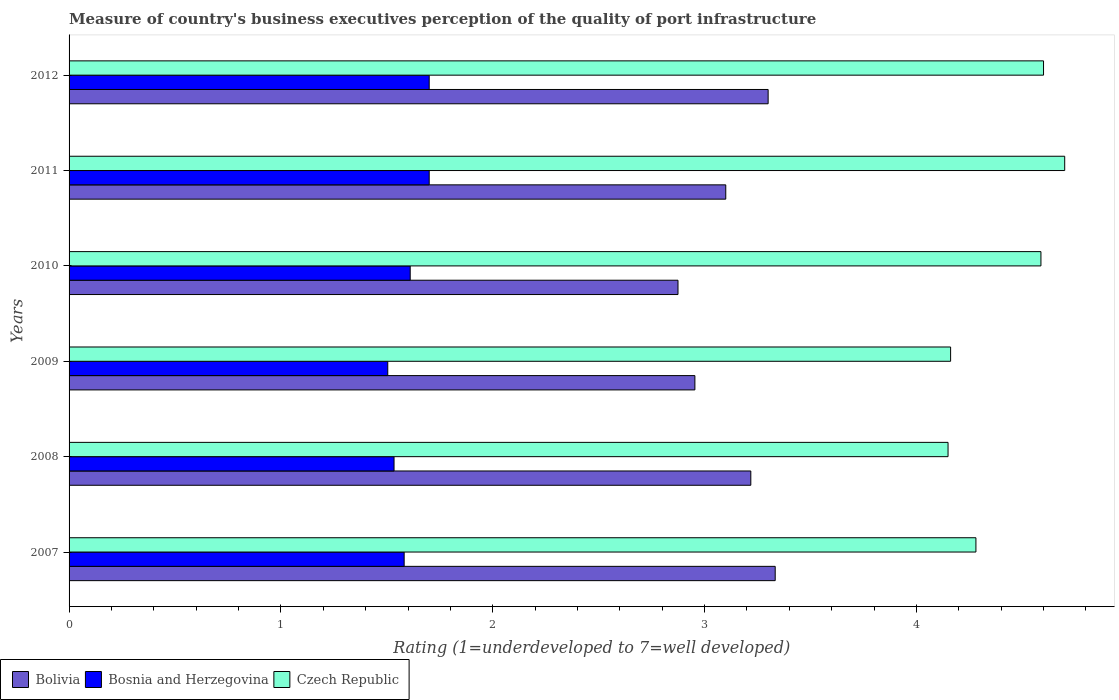How many different coloured bars are there?
Ensure brevity in your answer.  3. Are the number of bars per tick equal to the number of legend labels?
Your answer should be very brief. Yes. Are the number of bars on each tick of the Y-axis equal?
Your answer should be very brief. Yes. How many bars are there on the 3rd tick from the top?
Ensure brevity in your answer.  3. How many bars are there on the 1st tick from the bottom?
Your response must be concise. 3. In how many cases, is the number of bars for a given year not equal to the number of legend labels?
Your response must be concise. 0. Across all years, what is the minimum ratings of the quality of port infrastructure in Bosnia and Herzegovina?
Make the answer very short. 1.5. In which year was the ratings of the quality of port infrastructure in Bolivia minimum?
Provide a succinct answer. 2010. What is the total ratings of the quality of port infrastructure in Czech Republic in the graph?
Keep it short and to the point. 26.48. What is the difference between the ratings of the quality of port infrastructure in Bolivia in 2008 and that in 2011?
Make the answer very short. 0.12. What is the difference between the ratings of the quality of port infrastructure in Czech Republic in 2011 and the ratings of the quality of port infrastructure in Bolivia in 2008?
Keep it short and to the point. 1.48. What is the average ratings of the quality of port infrastructure in Bolivia per year?
Offer a terse response. 3.13. In the year 2009, what is the difference between the ratings of the quality of port infrastructure in Bosnia and Herzegovina and ratings of the quality of port infrastructure in Bolivia?
Offer a very short reply. -1.45. In how many years, is the ratings of the quality of port infrastructure in Bolivia greater than 3.6 ?
Your answer should be compact. 0. What is the ratio of the ratings of the quality of port infrastructure in Czech Republic in 2007 to that in 2012?
Provide a short and direct response. 0.93. Is the ratings of the quality of port infrastructure in Bosnia and Herzegovina in 2010 less than that in 2011?
Give a very brief answer. Yes. Is the difference between the ratings of the quality of port infrastructure in Bosnia and Herzegovina in 2008 and 2009 greater than the difference between the ratings of the quality of port infrastructure in Bolivia in 2008 and 2009?
Keep it short and to the point. No. What is the difference between the highest and the second highest ratings of the quality of port infrastructure in Czech Republic?
Make the answer very short. 0.1. What is the difference between the highest and the lowest ratings of the quality of port infrastructure in Czech Republic?
Give a very brief answer. 0.55. In how many years, is the ratings of the quality of port infrastructure in Czech Republic greater than the average ratings of the quality of port infrastructure in Czech Republic taken over all years?
Offer a very short reply. 3. What does the 1st bar from the top in 2007 represents?
Provide a succinct answer. Czech Republic. What does the 1st bar from the bottom in 2011 represents?
Provide a succinct answer. Bolivia. Is it the case that in every year, the sum of the ratings of the quality of port infrastructure in Bolivia and ratings of the quality of port infrastructure in Czech Republic is greater than the ratings of the quality of port infrastructure in Bosnia and Herzegovina?
Offer a terse response. Yes. How many bars are there?
Make the answer very short. 18. Are all the bars in the graph horizontal?
Provide a succinct answer. Yes. What is the difference between two consecutive major ticks on the X-axis?
Provide a succinct answer. 1. Are the values on the major ticks of X-axis written in scientific E-notation?
Your response must be concise. No. Where does the legend appear in the graph?
Provide a short and direct response. Bottom left. How many legend labels are there?
Give a very brief answer. 3. What is the title of the graph?
Your answer should be compact. Measure of country's business executives perception of the quality of port infrastructure. Does "Costa Rica" appear as one of the legend labels in the graph?
Provide a short and direct response. No. What is the label or title of the X-axis?
Provide a succinct answer. Rating (1=underdeveloped to 7=well developed). What is the Rating (1=underdeveloped to 7=well developed) of Bolivia in 2007?
Offer a very short reply. 3.33. What is the Rating (1=underdeveloped to 7=well developed) in Bosnia and Herzegovina in 2007?
Make the answer very short. 1.58. What is the Rating (1=underdeveloped to 7=well developed) of Czech Republic in 2007?
Give a very brief answer. 4.28. What is the Rating (1=underdeveloped to 7=well developed) in Bolivia in 2008?
Give a very brief answer. 3.22. What is the Rating (1=underdeveloped to 7=well developed) in Bosnia and Herzegovina in 2008?
Keep it short and to the point. 1.53. What is the Rating (1=underdeveloped to 7=well developed) of Czech Republic in 2008?
Ensure brevity in your answer.  4.15. What is the Rating (1=underdeveloped to 7=well developed) in Bolivia in 2009?
Your answer should be very brief. 2.95. What is the Rating (1=underdeveloped to 7=well developed) in Bosnia and Herzegovina in 2009?
Offer a very short reply. 1.5. What is the Rating (1=underdeveloped to 7=well developed) of Czech Republic in 2009?
Offer a terse response. 4.16. What is the Rating (1=underdeveloped to 7=well developed) in Bolivia in 2010?
Your response must be concise. 2.87. What is the Rating (1=underdeveloped to 7=well developed) in Bosnia and Herzegovina in 2010?
Make the answer very short. 1.61. What is the Rating (1=underdeveloped to 7=well developed) in Czech Republic in 2010?
Your answer should be very brief. 4.59. What is the Rating (1=underdeveloped to 7=well developed) in Bosnia and Herzegovina in 2011?
Ensure brevity in your answer.  1.7. What is the Rating (1=underdeveloped to 7=well developed) of Bolivia in 2012?
Make the answer very short. 3.3. What is the Rating (1=underdeveloped to 7=well developed) in Czech Republic in 2012?
Provide a short and direct response. 4.6. Across all years, what is the maximum Rating (1=underdeveloped to 7=well developed) of Bolivia?
Keep it short and to the point. 3.33. Across all years, what is the maximum Rating (1=underdeveloped to 7=well developed) of Bosnia and Herzegovina?
Your response must be concise. 1.7. Across all years, what is the minimum Rating (1=underdeveloped to 7=well developed) of Bolivia?
Offer a terse response. 2.87. Across all years, what is the minimum Rating (1=underdeveloped to 7=well developed) of Bosnia and Herzegovina?
Provide a short and direct response. 1.5. Across all years, what is the minimum Rating (1=underdeveloped to 7=well developed) of Czech Republic?
Offer a terse response. 4.15. What is the total Rating (1=underdeveloped to 7=well developed) in Bolivia in the graph?
Keep it short and to the point. 18.78. What is the total Rating (1=underdeveloped to 7=well developed) of Bosnia and Herzegovina in the graph?
Keep it short and to the point. 9.63. What is the total Rating (1=underdeveloped to 7=well developed) of Czech Republic in the graph?
Your answer should be compact. 26.48. What is the difference between the Rating (1=underdeveloped to 7=well developed) of Bolivia in 2007 and that in 2008?
Make the answer very short. 0.12. What is the difference between the Rating (1=underdeveloped to 7=well developed) of Bosnia and Herzegovina in 2007 and that in 2008?
Your response must be concise. 0.05. What is the difference between the Rating (1=underdeveloped to 7=well developed) of Czech Republic in 2007 and that in 2008?
Offer a terse response. 0.13. What is the difference between the Rating (1=underdeveloped to 7=well developed) of Bolivia in 2007 and that in 2009?
Ensure brevity in your answer.  0.38. What is the difference between the Rating (1=underdeveloped to 7=well developed) of Bosnia and Herzegovina in 2007 and that in 2009?
Ensure brevity in your answer.  0.08. What is the difference between the Rating (1=underdeveloped to 7=well developed) of Czech Republic in 2007 and that in 2009?
Provide a succinct answer. 0.12. What is the difference between the Rating (1=underdeveloped to 7=well developed) of Bolivia in 2007 and that in 2010?
Your answer should be compact. 0.46. What is the difference between the Rating (1=underdeveloped to 7=well developed) in Bosnia and Herzegovina in 2007 and that in 2010?
Your answer should be very brief. -0.03. What is the difference between the Rating (1=underdeveloped to 7=well developed) in Czech Republic in 2007 and that in 2010?
Your answer should be very brief. -0.31. What is the difference between the Rating (1=underdeveloped to 7=well developed) of Bolivia in 2007 and that in 2011?
Provide a succinct answer. 0.23. What is the difference between the Rating (1=underdeveloped to 7=well developed) of Bosnia and Herzegovina in 2007 and that in 2011?
Offer a terse response. -0.12. What is the difference between the Rating (1=underdeveloped to 7=well developed) of Czech Republic in 2007 and that in 2011?
Provide a succinct answer. -0.42. What is the difference between the Rating (1=underdeveloped to 7=well developed) of Bosnia and Herzegovina in 2007 and that in 2012?
Make the answer very short. -0.12. What is the difference between the Rating (1=underdeveloped to 7=well developed) of Czech Republic in 2007 and that in 2012?
Offer a very short reply. -0.32. What is the difference between the Rating (1=underdeveloped to 7=well developed) of Bolivia in 2008 and that in 2009?
Your answer should be very brief. 0.26. What is the difference between the Rating (1=underdeveloped to 7=well developed) in Bosnia and Herzegovina in 2008 and that in 2009?
Keep it short and to the point. 0.03. What is the difference between the Rating (1=underdeveloped to 7=well developed) in Czech Republic in 2008 and that in 2009?
Provide a short and direct response. -0.01. What is the difference between the Rating (1=underdeveloped to 7=well developed) of Bolivia in 2008 and that in 2010?
Give a very brief answer. 0.34. What is the difference between the Rating (1=underdeveloped to 7=well developed) in Bosnia and Herzegovina in 2008 and that in 2010?
Provide a succinct answer. -0.08. What is the difference between the Rating (1=underdeveloped to 7=well developed) of Czech Republic in 2008 and that in 2010?
Provide a succinct answer. -0.44. What is the difference between the Rating (1=underdeveloped to 7=well developed) of Bolivia in 2008 and that in 2011?
Make the answer very short. 0.12. What is the difference between the Rating (1=underdeveloped to 7=well developed) of Bosnia and Herzegovina in 2008 and that in 2011?
Your answer should be very brief. -0.17. What is the difference between the Rating (1=underdeveloped to 7=well developed) of Czech Republic in 2008 and that in 2011?
Offer a very short reply. -0.55. What is the difference between the Rating (1=underdeveloped to 7=well developed) of Bolivia in 2008 and that in 2012?
Provide a succinct answer. -0.08. What is the difference between the Rating (1=underdeveloped to 7=well developed) in Bosnia and Herzegovina in 2008 and that in 2012?
Offer a very short reply. -0.17. What is the difference between the Rating (1=underdeveloped to 7=well developed) of Czech Republic in 2008 and that in 2012?
Offer a terse response. -0.45. What is the difference between the Rating (1=underdeveloped to 7=well developed) of Bolivia in 2009 and that in 2010?
Offer a terse response. 0.08. What is the difference between the Rating (1=underdeveloped to 7=well developed) in Bosnia and Herzegovina in 2009 and that in 2010?
Offer a terse response. -0.11. What is the difference between the Rating (1=underdeveloped to 7=well developed) in Czech Republic in 2009 and that in 2010?
Keep it short and to the point. -0.43. What is the difference between the Rating (1=underdeveloped to 7=well developed) of Bolivia in 2009 and that in 2011?
Ensure brevity in your answer.  -0.15. What is the difference between the Rating (1=underdeveloped to 7=well developed) of Bosnia and Herzegovina in 2009 and that in 2011?
Provide a short and direct response. -0.2. What is the difference between the Rating (1=underdeveloped to 7=well developed) of Czech Republic in 2009 and that in 2011?
Keep it short and to the point. -0.54. What is the difference between the Rating (1=underdeveloped to 7=well developed) of Bolivia in 2009 and that in 2012?
Offer a very short reply. -0.35. What is the difference between the Rating (1=underdeveloped to 7=well developed) in Bosnia and Herzegovina in 2009 and that in 2012?
Provide a succinct answer. -0.2. What is the difference between the Rating (1=underdeveloped to 7=well developed) of Czech Republic in 2009 and that in 2012?
Your response must be concise. -0.44. What is the difference between the Rating (1=underdeveloped to 7=well developed) of Bolivia in 2010 and that in 2011?
Offer a very short reply. -0.23. What is the difference between the Rating (1=underdeveloped to 7=well developed) of Bosnia and Herzegovina in 2010 and that in 2011?
Provide a short and direct response. -0.09. What is the difference between the Rating (1=underdeveloped to 7=well developed) in Czech Republic in 2010 and that in 2011?
Provide a short and direct response. -0.11. What is the difference between the Rating (1=underdeveloped to 7=well developed) in Bolivia in 2010 and that in 2012?
Make the answer very short. -0.43. What is the difference between the Rating (1=underdeveloped to 7=well developed) in Bosnia and Herzegovina in 2010 and that in 2012?
Make the answer very short. -0.09. What is the difference between the Rating (1=underdeveloped to 7=well developed) in Czech Republic in 2010 and that in 2012?
Your answer should be compact. -0.01. What is the difference between the Rating (1=underdeveloped to 7=well developed) in Czech Republic in 2011 and that in 2012?
Give a very brief answer. 0.1. What is the difference between the Rating (1=underdeveloped to 7=well developed) in Bolivia in 2007 and the Rating (1=underdeveloped to 7=well developed) in Bosnia and Herzegovina in 2008?
Your answer should be compact. 1.8. What is the difference between the Rating (1=underdeveloped to 7=well developed) in Bolivia in 2007 and the Rating (1=underdeveloped to 7=well developed) in Czech Republic in 2008?
Offer a very short reply. -0.82. What is the difference between the Rating (1=underdeveloped to 7=well developed) in Bosnia and Herzegovina in 2007 and the Rating (1=underdeveloped to 7=well developed) in Czech Republic in 2008?
Ensure brevity in your answer.  -2.57. What is the difference between the Rating (1=underdeveloped to 7=well developed) in Bolivia in 2007 and the Rating (1=underdeveloped to 7=well developed) in Bosnia and Herzegovina in 2009?
Your response must be concise. 1.83. What is the difference between the Rating (1=underdeveloped to 7=well developed) in Bolivia in 2007 and the Rating (1=underdeveloped to 7=well developed) in Czech Republic in 2009?
Give a very brief answer. -0.83. What is the difference between the Rating (1=underdeveloped to 7=well developed) in Bosnia and Herzegovina in 2007 and the Rating (1=underdeveloped to 7=well developed) in Czech Republic in 2009?
Make the answer very short. -2.58. What is the difference between the Rating (1=underdeveloped to 7=well developed) in Bolivia in 2007 and the Rating (1=underdeveloped to 7=well developed) in Bosnia and Herzegovina in 2010?
Provide a short and direct response. 1.72. What is the difference between the Rating (1=underdeveloped to 7=well developed) of Bolivia in 2007 and the Rating (1=underdeveloped to 7=well developed) of Czech Republic in 2010?
Your answer should be compact. -1.25. What is the difference between the Rating (1=underdeveloped to 7=well developed) in Bosnia and Herzegovina in 2007 and the Rating (1=underdeveloped to 7=well developed) in Czech Republic in 2010?
Your answer should be very brief. -3.01. What is the difference between the Rating (1=underdeveloped to 7=well developed) in Bolivia in 2007 and the Rating (1=underdeveloped to 7=well developed) in Bosnia and Herzegovina in 2011?
Give a very brief answer. 1.63. What is the difference between the Rating (1=underdeveloped to 7=well developed) of Bolivia in 2007 and the Rating (1=underdeveloped to 7=well developed) of Czech Republic in 2011?
Give a very brief answer. -1.37. What is the difference between the Rating (1=underdeveloped to 7=well developed) in Bosnia and Herzegovina in 2007 and the Rating (1=underdeveloped to 7=well developed) in Czech Republic in 2011?
Offer a terse response. -3.12. What is the difference between the Rating (1=underdeveloped to 7=well developed) of Bolivia in 2007 and the Rating (1=underdeveloped to 7=well developed) of Bosnia and Herzegovina in 2012?
Provide a succinct answer. 1.63. What is the difference between the Rating (1=underdeveloped to 7=well developed) in Bolivia in 2007 and the Rating (1=underdeveloped to 7=well developed) in Czech Republic in 2012?
Make the answer very short. -1.27. What is the difference between the Rating (1=underdeveloped to 7=well developed) of Bosnia and Herzegovina in 2007 and the Rating (1=underdeveloped to 7=well developed) of Czech Republic in 2012?
Make the answer very short. -3.02. What is the difference between the Rating (1=underdeveloped to 7=well developed) in Bolivia in 2008 and the Rating (1=underdeveloped to 7=well developed) in Bosnia and Herzegovina in 2009?
Provide a succinct answer. 1.71. What is the difference between the Rating (1=underdeveloped to 7=well developed) in Bolivia in 2008 and the Rating (1=underdeveloped to 7=well developed) in Czech Republic in 2009?
Ensure brevity in your answer.  -0.94. What is the difference between the Rating (1=underdeveloped to 7=well developed) of Bosnia and Herzegovina in 2008 and the Rating (1=underdeveloped to 7=well developed) of Czech Republic in 2009?
Provide a short and direct response. -2.63. What is the difference between the Rating (1=underdeveloped to 7=well developed) of Bolivia in 2008 and the Rating (1=underdeveloped to 7=well developed) of Bosnia and Herzegovina in 2010?
Keep it short and to the point. 1.61. What is the difference between the Rating (1=underdeveloped to 7=well developed) of Bolivia in 2008 and the Rating (1=underdeveloped to 7=well developed) of Czech Republic in 2010?
Give a very brief answer. -1.37. What is the difference between the Rating (1=underdeveloped to 7=well developed) of Bosnia and Herzegovina in 2008 and the Rating (1=underdeveloped to 7=well developed) of Czech Republic in 2010?
Offer a very short reply. -3.05. What is the difference between the Rating (1=underdeveloped to 7=well developed) of Bolivia in 2008 and the Rating (1=underdeveloped to 7=well developed) of Bosnia and Herzegovina in 2011?
Keep it short and to the point. 1.52. What is the difference between the Rating (1=underdeveloped to 7=well developed) of Bolivia in 2008 and the Rating (1=underdeveloped to 7=well developed) of Czech Republic in 2011?
Provide a succinct answer. -1.48. What is the difference between the Rating (1=underdeveloped to 7=well developed) in Bosnia and Herzegovina in 2008 and the Rating (1=underdeveloped to 7=well developed) in Czech Republic in 2011?
Provide a short and direct response. -3.17. What is the difference between the Rating (1=underdeveloped to 7=well developed) of Bolivia in 2008 and the Rating (1=underdeveloped to 7=well developed) of Bosnia and Herzegovina in 2012?
Your answer should be very brief. 1.52. What is the difference between the Rating (1=underdeveloped to 7=well developed) in Bolivia in 2008 and the Rating (1=underdeveloped to 7=well developed) in Czech Republic in 2012?
Provide a succinct answer. -1.38. What is the difference between the Rating (1=underdeveloped to 7=well developed) in Bosnia and Herzegovina in 2008 and the Rating (1=underdeveloped to 7=well developed) in Czech Republic in 2012?
Keep it short and to the point. -3.07. What is the difference between the Rating (1=underdeveloped to 7=well developed) of Bolivia in 2009 and the Rating (1=underdeveloped to 7=well developed) of Bosnia and Herzegovina in 2010?
Your response must be concise. 1.34. What is the difference between the Rating (1=underdeveloped to 7=well developed) of Bolivia in 2009 and the Rating (1=underdeveloped to 7=well developed) of Czech Republic in 2010?
Offer a very short reply. -1.63. What is the difference between the Rating (1=underdeveloped to 7=well developed) in Bosnia and Herzegovina in 2009 and the Rating (1=underdeveloped to 7=well developed) in Czech Republic in 2010?
Offer a terse response. -3.08. What is the difference between the Rating (1=underdeveloped to 7=well developed) in Bolivia in 2009 and the Rating (1=underdeveloped to 7=well developed) in Bosnia and Herzegovina in 2011?
Provide a short and direct response. 1.25. What is the difference between the Rating (1=underdeveloped to 7=well developed) in Bolivia in 2009 and the Rating (1=underdeveloped to 7=well developed) in Czech Republic in 2011?
Offer a terse response. -1.75. What is the difference between the Rating (1=underdeveloped to 7=well developed) in Bosnia and Herzegovina in 2009 and the Rating (1=underdeveloped to 7=well developed) in Czech Republic in 2011?
Ensure brevity in your answer.  -3.2. What is the difference between the Rating (1=underdeveloped to 7=well developed) of Bolivia in 2009 and the Rating (1=underdeveloped to 7=well developed) of Bosnia and Herzegovina in 2012?
Provide a succinct answer. 1.25. What is the difference between the Rating (1=underdeveloped to 7=well developed) of Bolivia in 2009 and the Rating (1=underdeveloped to 7=well developed) of Czech Republic in 2012?
Offer a terse response. -1.65. What is the difference between the Rating (1=underdeveloped to 7=well developed) of Bosnia and Herzegovina in 2009 and the Rating (1=underdeveloped to 7=well developed) of Czech Republic in 2012?
Offer a very short reply. -3.1. What is the difference between the Rating (1=underdeveloped to 7=well developed) in Bolivia in 2010 and the Rating (1=underdeveloped to 7=well developed) in Bosnia and Herzegovina in 2011?
Provide a short and direct response. 1.17. What is the difference between the Rating (1=underdeveloped to 7=well developed) in Bolivia in 2010 and the Rating (1=underdeveloped to 7=well developed) in Czech Republic in 2011?
Give a very brief answer. -1.83. What is the difference between the Rating (1=underdeveloped to 7=well developed) of Bosnia and Herzegovina in 2010 and the Rating (1=underdeveloped to 7=well developed) of Czech Republic in 2011?
Offer a terse response. -3.09. What is the difference between the Rating (1=underdeveloped to 7=well developed) in Bolivia in 2010 and the Rating (1=underdeveloped to 7=well developed) in Bosnia and Herzegovina in 2012?
Your answer should be compact. 1.17. What is the difference between the Rating (1=underdeveloped to 7=well developed) of Bolivia in 2010 and the Rating (1=underdeveloped to 7=well developed) of Czech Republic in 2012?
Offer a very short reply. -1.73. What is the difference between the Rating (1=underdeveloped to 7=well developed) in Bosnia and Herzegovina in 2010 and the Rating (1=underdeveloped to 7=well developed) in Czech Republic in 2012?
Make the answer very short. -2.99. What is the difference between the Rating (1=underdeveloped to 7=well developed) of Bolivia in 2011 and the Rating (1=underdeveloped to 7=well developed) of Bosnia and Herzegovina in 2012?
Keep it short and to the point. 1.4. What is the average Rating (1=underdeveloped to 7=well developed) of Bolivia per year?
Offer a terse response. 3.13. What is the average Rating (1=underdeveloped to 7=well developed) in Bosnia and Herzegovina per year?
Offer a terse response. 1.61. What is the average Rating (1=underdeveloped to 7=well developed) in Czech Republic per year?
Keep it short and to the point. 4.41. In the year 2007, what is the difference between the Rating (1=underdeveloped to 7=well developed) in Bolivia and Rating (1=underdeveloped to 7=well developed) in Bosnia and Herzegovina?
Provide a succinct answer. 1.75. In the year 2007, what is the difference between the Rating (1=underdeveloped to 7=well developed) in Bolivia and Rating (1=underdeveloped to 7=well developed) in Czech Republic?
Ensure brevity in your answer.  -0.95. In the year 2007, what is the difference between the Rating (1=underdeveloped to 7=well developed) of Bosnia and Herzegovina and Rating (1=underdeveloped to 7=well developed) of Czech Republic?
Your answer should be compact. -2.7. In the year 2008, what is the difference between the Rating (1=underdeveloped to 7=well developed) in Bolivia and Rating (1=underdeveloped to 7=well developed) in Bosnia and Herzegovina?
Provide a short and direct response. 1.68. In the year 2008, what is the difference between the Rating (1=underdeveloped to 7=well developed) of Bolivia and Rating (1=underdeveloped to 7=well developed) of Czech Republic?
Your response must be concise. -0.93. In the year 2008, what is the difference between the Rating (1=underdeveloped to 7=well developed) of Bosnia and Herzegovina and Rating (1=underdeveloped to 7=well developed) of Czech Republic?
Your response must be concise. -2.62. In the year 2009, what is the difference between the Rating (1=underdeveloped to 7=well developed) of Bolivia and Rating (1=underdeveloped to 7=well developed) of Bosnia and Herzegovina?
Make the answer very short. 1.45. In the year 2009, what is the difference between the Rating (1=underdeveloped to 7=well developed) of Bolivia and Rating (1=underdeveloped to 7=well developed) of Czech Republic?
Make the answer very short. -1.21. In the year 2009, what is the difference between the Rating (1=underdeveloped to 7=well developed) of Bosnia and Herzegovina and Rating (1=underdeveloped to 7=well developed) of Czech Republic?
Provide a short and direct response. -2.66. In the year 2010, what is the difference between the Rating (1=underdeveloped to 7=well developed) of Bolivia and Rating (1=underdeveloped to 7=well developed) of Bosnia and Herzegovina?
Provide a short and direct response. 1.26. In the year 2010, what is the difference between the Rating (1=underdeveloped to 7=well developed) of Bolivia and Rating (1=underdeveloped to 7=well developed) of Czech Republic?
Your answer should be compact. -1.71. In the year 2010, what is the difference between the Rating (1=underdeveloped to 7=well developed) in Bosnia and Herzegovina and Rating (1=underdeveloped to 7=well developed) in Czech Republic?
Your answer should be very brief. -2.98. In the year 2011, what is the difference between the Rating (1=underdeveloped to 7=well developed) of Bosnia and Herzegovina and Rating (1=underdeveloped to 7=well developed) of Czech Republic?
Give a very brief answer. -3. In the year 2012, what is the difference between the Rating (1=underdeveloped to 7=well developed) of Bolivia and Rating (1=underdeveloped to 7=well developed) of Bosnia and Herzegovina?
Offer a terse response. 1.6. In the year 2012, what is the difference between the Rating (1=underdeveloped to 7=well developed) in Bosnia and Herzegovina and Rating (1=underdeveloped to 7=well developed) in Czech Republic?
Offer a very short reply. -2.9. What is the ratio of the Rating (1=underdeveloped to 7=well developed) of Bolivia in 2007 to that in 2008?
Provide a short and direct response. 1.04. What is the ratio of the Rating (1=underdeveloped to 7=well developed) of Bosnia and Herzegovina in 2007 to that in 2008?
Your answer should be very brief. 1.03. What is the ratio of the Rating (1=underdeveloped to 7=well developed) of Czech Republic in 2007 to that in 2008?
Offer a terse response. 1.03. What is the ratio of the Rating (1=underdeveloped to 7=well developed) of Bolivia in 2007 to that in 2009?
Your answer should be very brief. 1.13. What is the ratio of the Rating (1=underdeveloped to 7=well developed) of Bosnia and Herzegovina in 2007 to that in 2009?
Keep it short and to the point. 1.05. What is the ratio of the Rating (1=underdeveloped to 7=well developed) of Czech Republic in 2007 to that in 2009?
Provide a short and direct response. 1.03. What is the ratio of the Rating (1=underdeveloped to 7=well developed) in Bolivia in 2007 to that in 2010?
Give a very brief answer. 1.16. What is the ratio of the Rating (1=underdeveloped to 7=well developed) of Bosnia and Herzegovina in 2007 to that in 2010?
Provide a short and direct response. 0.98. What is the ratio of the Rating (1=underdeveloped to 7=well developed) in Czech Republic in 2007 to that in 2010?
Your response must be concise. 0.93. What is the ratio of the Rating (1=underdeveloped to 7=well developed) of Bolivia in 2007 to that in 2011?
Offer a terse response. 1.08. What is the ratio of the Rating (1=underdeveloped to 7=well developed) in Bosnia and Herzegovina in 2007 to that in 2011?
Your answer should be compact. 0.93. What is the ratio of the Rating (1=underdeveloped to 7=well developed) of Czech Republic in 2007 to that in 2011?
Make the answer very short. 0.91. What is the ratio of the Rating (1=underdeveloped to 7=well developed) in Bosnia and Herzegovina in 2007 to that in 2012?
Your answer should be compact. 0.93. What is the ratio of the Rating (1=underdeveloped to 7=well developed) of Czech Republic in 2007 to that in 2012?
Offer a terse response. 0.93. What is the ratio of the Rating (1=underdeveloped to 7=well developed) of Bolivia in 2008 to that in 2009?
Give a very brief answer. 1.09. What is the ratio of the Rating (1=underdeveloped to 7=well developed) of Bosnia and Herzegovina in 2008 to that in 2009?
Your answer should be very brief. 1.02. What is the ratio of the Rating (1=underdeveloped to 7=well developed) in Czech Republic in 2008 to that in 2009?
Offer a terse response. 1. What is the ratio of the Rating (1=underdeveloped to 7=well developed) of Bolivia in 2008 to that in 2010?
Provide a succinct answer. 1.12. What is the ratio of the Rating (1=underdeveloped to 7=well developed) of Bosnia and Herzegovina in 2008 to that in 2010?
Make the answer very short. 0.95. What is the ratio of the Rating (1=underdeveloped to 7=well developed) in Czech Republic in 2008 to that in 2010?
Make the answer very short. 0.9. What is the ratio of the Rating (1=underdeveloped to 7=well developed) in Bolivia in 2008 to that in 2011?
Offer a very short reply. 1.04. What is the ratio of the Rating (1=underdeveloped to 7=well developed) in Bosnia and Herzegovina in 2008 to that in 2011?
Make the answer very short. 0.9. What is the ratio of the Rating (1=underdeveloped to 7=well developed) of Czech Republic in 2008 to that in 2011?
Provide a short and direct response. 0.88. What is the ratio of the Rating (1=underdeveloped to 7=well developed) of Bolivia in 2008 to that in 2012?
Provide a succinct answer. 0.98. What is the ratio of the Rating (1=underdeveloped to 7=well developed) of Bosnia and Herzegovina in 2008 to that in 2012?
Make the answer very short. 0.9. What is the ratio of the Rating (1=underdeveloped to 7=well developed) of Czech Republic in 2008 to that in 2012?
Keep it short and to the point. 0.9. What is the ratio of the Rating (1=underdeveloped to 7=well developed) of Bolivia in 2009 to that in 2010?
Provide a short and direct response. 1.03. What is the ratio of the Rating (1=underdeveloped to 7=well developed) of Bosnia and Herzegovina in 2009 to that in 2010?
Offer a very short reply. 0.93. What is the ratio of the Rating (1=underdeveloped to 7=well developed) of Czech Republic in 2009 to that in 2010?
Provide a succinct answer. 0.91. What is the ratio of the Rating (1=underdeveloped to 7=well developed) in Bolivia in 2009 to that in 2011?
Ensure brevity in your answer.  0.95. What is the ratio of the Rating (1=underdeveloped to 7=well developed) of Bosnia and Herzegovina in 2009 to that in 2011?
Your response must be concise. 0.89. What is the ratio of the Rating (1=underdeveloped to 7=well developed) of Czech Republic in 2009 to that in 2011?
Your answer should be compact. 0.89. What is the ratio of the Rating (1=underdeveloped to 7=well developed) in Bolivia in 2009 to that in 2012?
Offer a terse response. 0.9. What is the ratio of the Rating (1=underdeveloped to 7=well developed) in Bosnia and Herzegovina in 2009 to that in 2012?
Provide a short and direct response. 0.89. What is the ratio of the Rating (1=underdeveloped to 7=well developed) of Czech Republic in 2009 to that in 2012?
Keep it short and to the point. 0.9. What is the ratio of the Rating (1=underdeveloped to 7=well developed) of Bolivia in 2010 to that in 2011?
Offer a terse response. 0.93. What is the ratio of the Rating (1=underdeveloped to 7=well developed) in Bosnia and Herzegovina in 2010 to that in 2011?
Keep it short and to the point. 0.95. What is the ratio of the Rating (1=underdeveloped to 7=well developed) in Czech Republic in 2010 to that in 2011?
Keep it short and to the point. 0.98. What is the ratio of the Rating (1=underdeveloped to 7=well developed) of Bolivia in 2010 to that in 2012?
Your answer should be very brief. 0.87. What is the ratio of the Rating (1=underdeveloped to 7=well developed) in Bosnia and Herzegovina in 2010 to that in 2012?
Your answer should be compact. 0.95. What is the ratio of the Rating (1=underdeveloped to 7=well developed) of Czech Republic in 2010 to that in 2012?
Your response must be concise. 1. What is the ratio of the Rating (1=underdeveloped to 7=well developed) of Bolivia in 2011 to that in 2012?
Your answer should be compact. 0.94. What is the ratio of the Rating (1=underdeveloped to 7=well developed) in Bosnia and Herzegovina in 2011 to that in 2012?
Ensure brevity in your answer.  1. What is the ratio of the Rating (1=underdeveloped to 7=well developed) of Czech Republic in 2011 to that in 2012?
Ensure brevity in your answer.  1.02. What is the difference between the highest and the second highest Rating (1=underdeveloped to 7=well developed) of Bolivia?
Keep it short and to the point. 0.03. What is the difference between the highest and the second highest Rating (1=underdeveloped to 7=well developed) of Bosnia and Herzegovina?
Make the answer very short. 0. What is the difference between the highest and the lowest Rating (1=underdeveloped to 7=well developed) in Bolivia?
Your answer should be very brief. 0.46. What is the difference between the highest and the lowest Rating (1=underdeveloped to 7=well developed) in Bosnia and Herzegovina?
Your answer should be very brief. 0.2. What is the difference between the highest and the lowest Rating (1=underdeveloped to 7=well developed) in Czech Republic?
Provide a succinct answer. 0.55. 